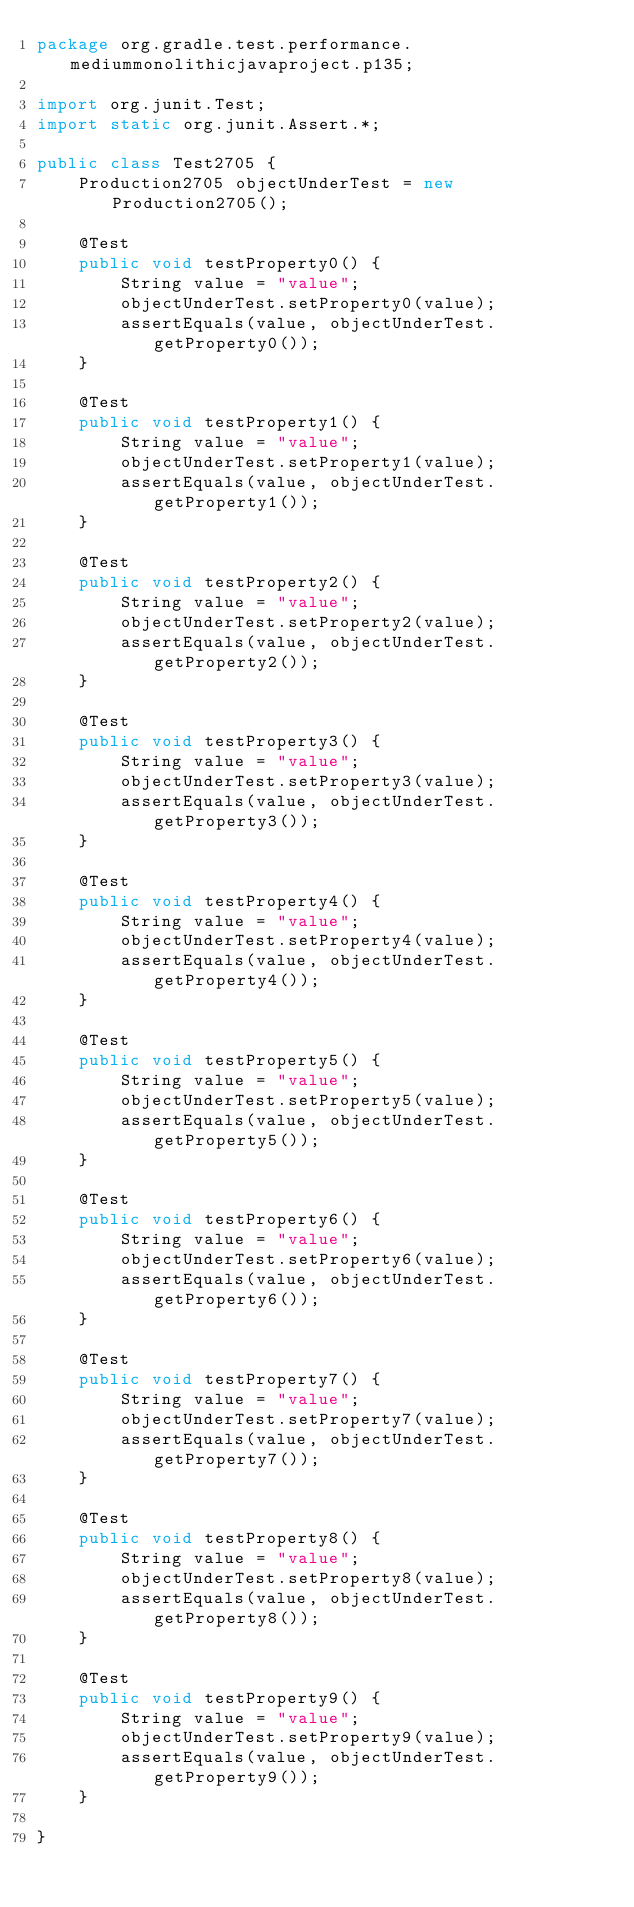<code> <loc_0><loc_0><loc_500><loc_500><_Java_>package org.gradle.test.performance.mediummonolithicjavaproject.p135;

import org.junit.Test;
import static org.junit.Assert.*;

public class Test2705 {  
    Production2705 objectUnderTest = new Production2705();     

    @Test
    public void testProperty0() {
        String value = "value";
        objectUnderTest.setProperty0(value);
        assertEquals(value, objectUnderTest.getProperty0());
    }

    @Test
    public void testProperty1() {
        String value = "value";
        objectUnderTest.setProperty1(value);
        assertEquals(value, objectUnderTest.getProperty1());
    }

    @Test
    public void testProperty2() {
        String value = "value";
        objectUnderTest.setProperty2(value);
        assertEquals(value, objectUnderTest.getProperty2());
    }

    @Test
    public void testProperty3() {
        String value = "value";
        objectUnderTest.setProperty3(value);
        assertEquals(value, objectUnderTest.getProperty3());
    }

    @Test
    public void testProperty4() {
        String value = "value";
        objectUnderTest.setProperty4(value);
        assertEquals(value, objectUnderTest.getProperty4());
    }

    @Test
    public void testProperty5() {
        String value = "value";
        objectUnderTest.setProperty5(value);
        assertEquals(value, objectUnderTest.getProperty5());
    }

    @Test
    public void testProperty6() {
        String value = "value";
        objectUnderTest.setProperty6(value);
        assertEquals(value, objectUnderTest.getProperty6());
    }

    @Test
    public void testProperty7() {
        String value = "value";
        objectUnderTest.setProperty7(value);
        assertEquals(value, objectUnderTest.getProperty7());
    }

    @Test
    public void testProperty8() {
        String value = "value";
        objectUnderTest.setProperty8(value);
        assertEquals(value, objectUnderTest.getProperty8());
    }

    @Test
    public void testProperty9() {
        String value = "value";
        objectUnderTest.setProperty9(value);
        assertEquals(value, objectUnderTest.getProperty9());
    }

}</code> 